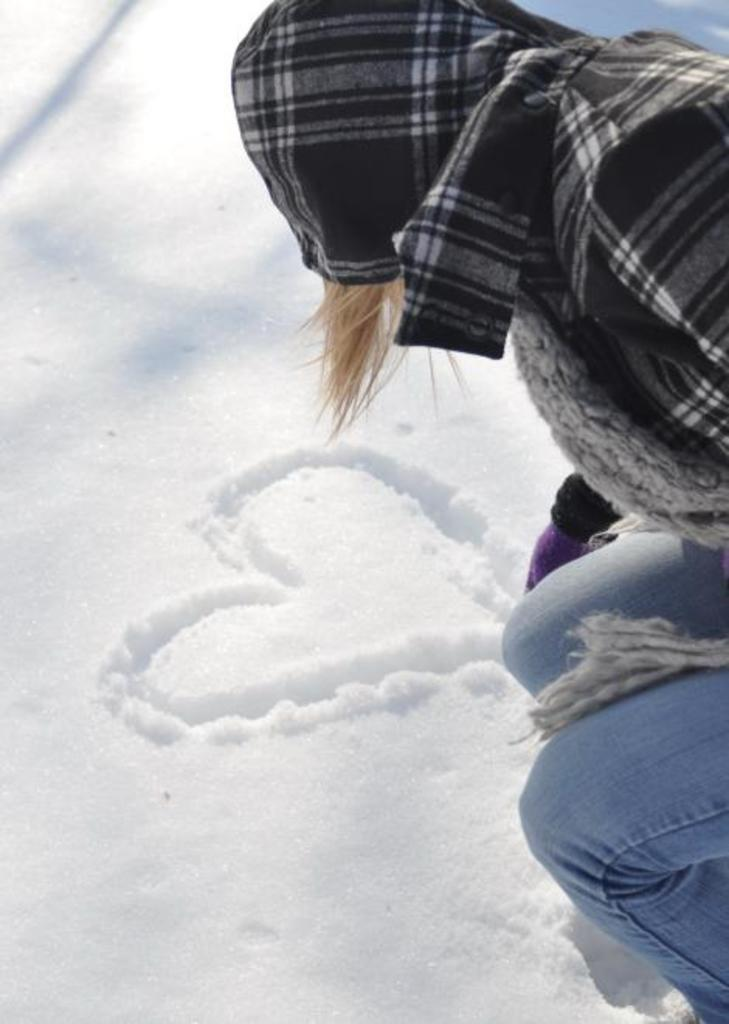Who or what is present in the image? There is a person in the image. What is the weather like in the image? There is snow in the image. Can you describe any additional details in the image? There is a heart symbol in the snow. What type of pizzas can be seen in the aftermath of the snowstorm in the image? There is no mention of pizzas or a snowstorm in the image, so it cannot be determined if any pizzas are present. 